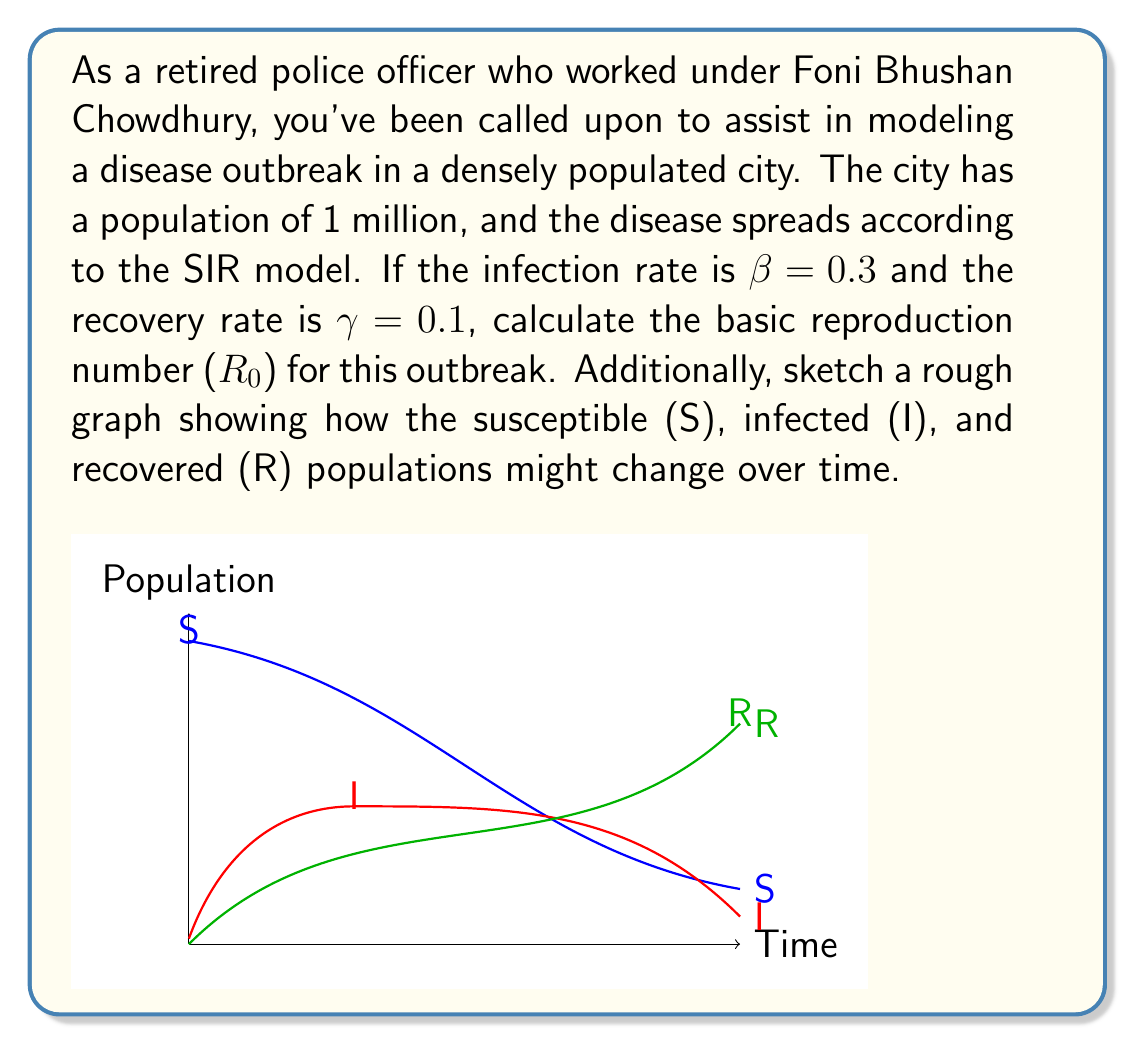Provide a solution to this math problem. To solve this problem, we'll follow these steps:

1) The basic reproduction number ($R_0$) in the SIR model is given by the formula:

   $$R_0 = \frac{\beta}{\gamma}$$

   where $\beta$ is the infection rate and $\gamma$ is the recovery rate.

2) We're given that $\beta = 0.3$ and $\gamma = 0.1$. Let's substitute these values:

   $$R_0 = \frac{0.3}{0.1} = 3$$

3) Interpreting this result: An $R_0$ of 3 means that, on average, each infected person will infect 3 others in a fully susceptible population.

4) Regarding the graph:
   - The susceptible population (S) starts high and decreases over time.
   - The infected population (I) starts low, increases to a peak, then decreases.
   - The recovered population (R) starts at zero and increases over time.

   The exact shapes of these curves depend on initial conditions and parameter values, but the sketch provides a qualitative representation of a typical SIR model progression.

5) In the context of your police experience, this model could help in planning quarantine measures, allocating medical resources, and predicting the duration of the outbreak.
Answer: $R_0 = 3$ 